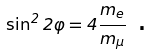Convert formula to latex. <formula><loc_0><loc_0><loc_500><loc_500>\sin ^ { 2 } 2 \varphi = 4 \frac { m _ { e } } { m _ { \mu } } \text { .}</formula> 